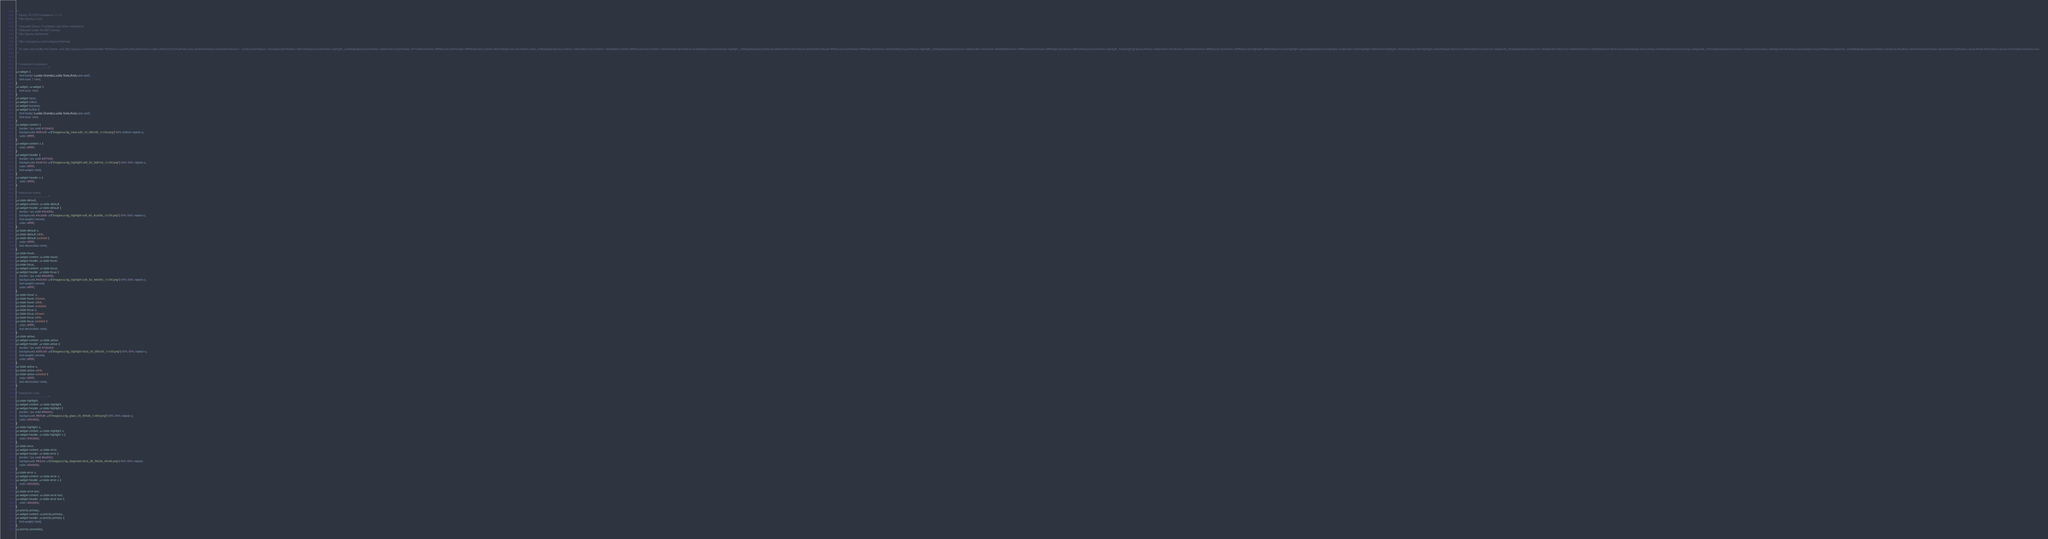Convert code to text. <code><loc_0><loc_0><loc_500><loc_500><_CSS_>/*!
 * jQuery UI CSS Framework 1.11.4
 * http://jqueryui.com
 *
 * Copyright jQuery Foundation and other contributors
 * Released under the MIT license.
 * http://jquery.org/license
 *
 * http://api.jqueryui.com/category/theming/
 *
 * To view and modify this theme, visit http://jqueryui.com/themeroller/?ffDefault=Lucida%20Grande%2CLucida%20Sans%2CArial%2Csans-serif&fwDefault=normal&fsDefault=1.1em&cornerRadius=10px&bgColorHeader=3a8104&bgTextureHeader=highlight_soft&bgImgOpacityHeader=33&borderColorHeader=3f7506&fcHeader=ffffff&iconColorHeader=ffffff&bgColorContent=285c00&bgTextureContent=inset_soft&bgImgOpacityContent=10&borderColorContent=72b42d&fcContent=ffffff&iconColorContent=72b42d&bgColorDefault=4ca20b&bgTextureDefault=highlight_soft&bgImgOpacityDefault=60&borderColorDefault=45930b&fcDefault=ffffff&iconColorDefault=ffffff&bgColorHover=4eb305&bgTextureHover=highlight_soft&bgImgOpacityHover=50&borderColorHover=8bd83b&fcHover=ffffff&iconColorHover=ffffff&bgColorActive=285c00&bgTextureActive=highlight_hard&bgImgOpacityActive=30&borderColorActive=72b42d&fcActive=ffffff&iconColorActive=ffffff&bgColorHighlight=fbf5d0&bgTextureHighlight=glass&bgImgOpacityHighlight=55&borderColorHighlight=f9dd34&fcHighlight=363636&iconColorHighlight=4eb305&bgColorError=ffdc2e&bgTextureError=diagonals_thick&bgImgOpacityError=95&borderColorError=fad000&fcError=2b2b2b&iconColorError=cd0a0a&bgColorOverlay=444444&bgTextureOverlay=diagonals_thick&bgImgOpacityOverlay=15&opacityOverlay=30&bgColorShadow=aaaaaa&bgTextureShadow=diagonals_small&bgImgOpacityShadow=0&opacityShadow=30&thicknessShadow=0px&offsetTopShadow=4px&offsetLeftShadow=4px&cornerRadiusShadow=4px
 */


/* Component containers
----------------------------------*/
.ui-widget {
	font-family: Lucida Grande,Lucida Sans,Arial,sans-serif;
	font-size: 1.1em;
}
.ui-widget .ui-widget {
	font-size: 1em;
}
.ui-widget input,
.ui-widget select,
.ui-widget textarea,
.ui-widget button {
	font-family: Lucida Grande,Lucida Sans,Arial,sans-serif;
	font-size: 1em;
}
.ui-widget-content {
	border: 1px solid #72b42d;
	background: #285c00 url("images/ui-bg_inset-soft_10_285c00_1x100.png") 50% bottom repeat-x;
	color: #ffffff;
}
.ui-widget-content a {
	color: #ffffff;
}
.ui-widget-header {
	border: 1px solid #3f7506;
	background: #3a8104 url("images/ui-bg_highlight-soft_33_3a8104_1x100.png") 50% 50% repeat-x;
	color: #ffffff;
	font-weight: bold;
}
.ui-widget-header a {
	color: #ffffff;
}

/* Interaction states
----------------------------------*/
.ui-state-default,
.ui-widget-content .ui-state-default,
.ui-widget-header .ui-state-default {
	border: 1px solid #45930b;
	background: #4ca20b url("images/ui-bg_highlight-soft_60_4ca20b_1x100.png") 50% 50% repeat-x;
	font-weight: normal;
	color: #ffffff;
}
.ui-state-default a,
.ui-state-default a:link,
.ui-state-default a:visited {
	color: #ffffff;
	text-decoration: none;
}
.ui-state-hover,
.ui-widget-content .ui-state-hover,
.ui-widget-header .ui-state-hover,
.ui-state-focus,
.ui-widget-content .ui-state-focus,
.ui-widget-header .ui-state-focus {
	border: 1px solid #8bd83b;
	background: #4eb305 url("images/ui-bg_highlight-soft_50_4eb305_1x100.png") 50% 50% repeat-x;
	font-weight: normal;
	color: #ffffff;
}
.ui-state-hover a,
.ui-state-hover a:hover,
.ui-state-hover a:link,
.ui-state-hover a:visited,
.ui-state-focus a,
.ui-state-focus a:hover,
.ui-state-focus a:link,
.ui-state-focus a:visited {
	color: #ffffff;
	text-decoration: none;
}
.ui-state-active,
.ui-widget-content .ui-state-active,
.ui-widget-header .ui-state-active {
	border: 1px solid #72b42d;
	background: #285c00 url("images/ui-bg_highlight-hard_30_285c00_1x100.png") 50% 50% repeat-x;
	font-weight: normal;
	color: #ffffff;
}
.ui-state-active a,
.ui-state-active a:link,
.ui-state-active a:visited {
	color: #ffffff;
	text-decoration: none;
}

/* Interaction Cues
----------------------------------*/
.ui-state-highlight,
.ui-widget-content .ui-state-highlight,
.ui-widget-header .ui-state-highlight {
	border: 1px solid #f9dd34;
	background: #fbf5d0 url("images/ui-bg_glass_55_fbf5d0_1x400.png") 50% 50% repeat-x;
	color: #363636;
}
.ui-state-highlight a,
.ui-widget-content .ui-state-highlight a,
.ui-widget-header .ui-state-highlight a {
	color: #363636;
}
.ui-state-error,
.ui-widget-content .ui-state-error,
.ui-widget-header .ui-state-error {
	border: 1px solid #fad000;
	background: #ffdc2e url("images/ui-bg_diagonals-thick_95_ffdc2e_40x40.png") 50% 50% repeat;
	color: #2b2b2b;
}
.ui-state-error a,
.ui-widget-content .ui-state-error a,
.ui-widget-header .ui-state-error a {
	color: #2b2b2b;
}
.ui-state-error-text,
.ui-widget-content .ui-state-error-text,
.ui-widget-header .ui-state-error-text {
	color: #2b2b2b;
}
.ui-priority-primary,
.ui-widget-content .ui-priority-primary,
.ui-widget-header .ui-priority-primary {
	font-weight: bold;
}
.ui-priority-secondary,</code> 